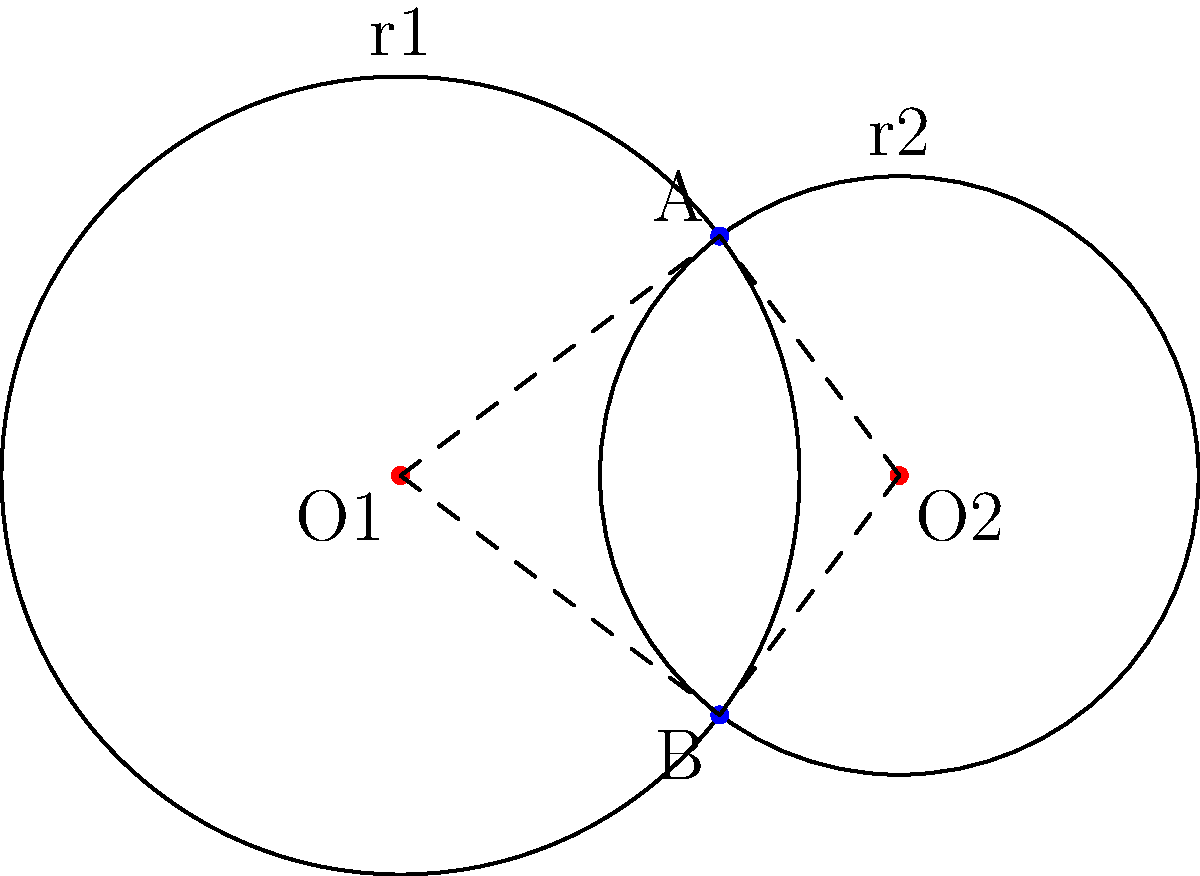In a Gitlab server cluster visualization, two nodes are represented as circles with centers O1(0,0) and O2(5,0), and radii r1=4 and r2=3 respectively. Calculate the y-coordinate of the intersection points A and B of these circles. To find the y-coordinate of the intersection points, we can follow these steps:

1) The equation of circle 1 is: $x^2 + y^2 = 16$
2) The equation of circle 2 is: $(x-5)^2 + y^2 = 9$

3) At the intersection points, both equations are satisfied. Subtracting equation 2 from equation 1:
   $x^2 - (x-5)^2 = 16 - 9$
   $x^2 - (x^2-10x+25) = 7$
   $10x - 25 = 7$
   $10x = 32$
   $x = 3.2$

4) Substitute this x-value back into the equation of circle 1:
   $3.2^2 + y^2 = 16$
   $10.24 + y^2 = 16$
   $y^2 = 5.76$

5) Take the square root of both sides:
   $y = \pm \sqrt{5.76} = \pm 2.4$

Therefore, the y-coordinates of the intersection points A and B are 2.4 and -2.4.
Answer: $\pm 2.4$ 